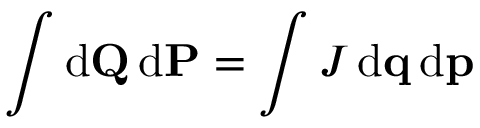<formula> <loc_0><loc_0><loc_500><loc_500>\int d Q \, d P = \int J \, d q \, d p</formula> 